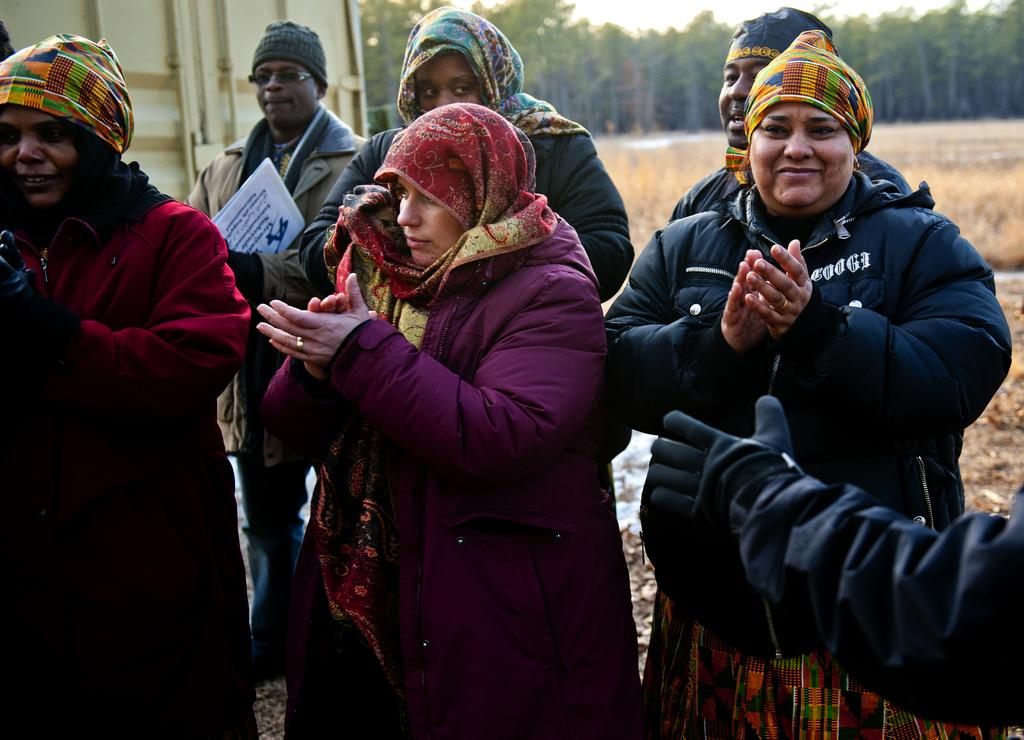Who or what can be seen in the foreground of the image? There are people in the foreground of the image. Can you describe the setting in which the people are located? The people are in the foreground, and there is grass and trees visible in the background of the image. What else can be seen in the background of the image? There is a container in the background of the image. What type of leather is visible on the door in the image? There is no door or leather present in the image. What grade does the person in the image receive for their performance? There is no indication of a performance or grade in the image. 